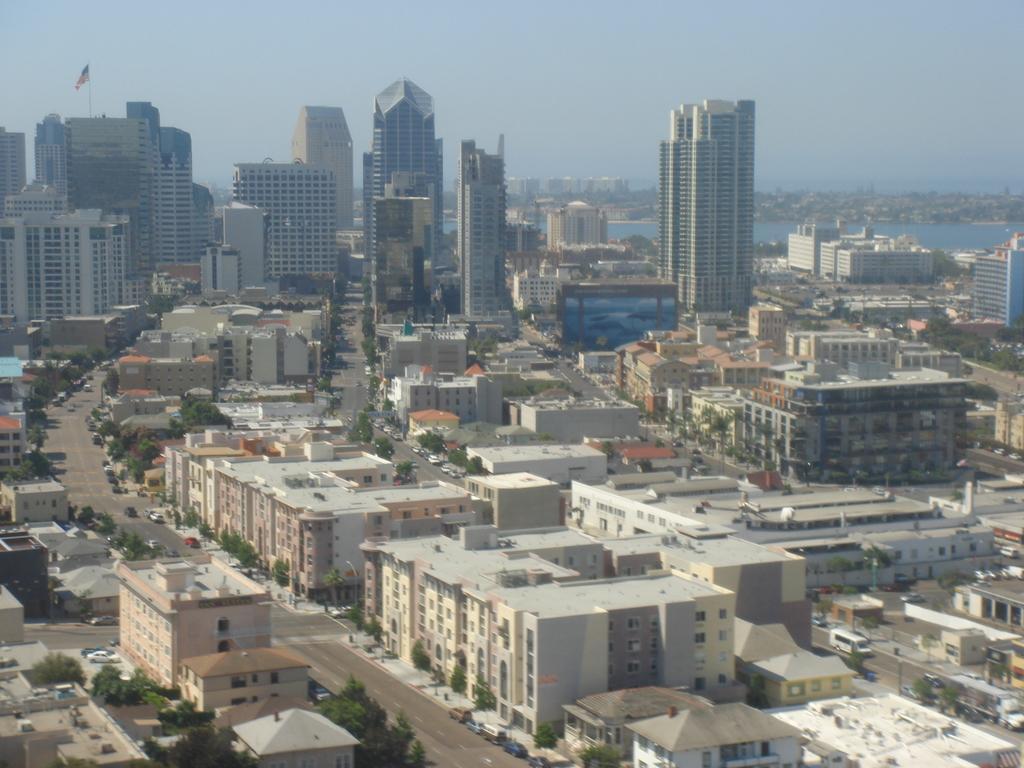In one or two sentences, can you explain what this image depicts? In this image we can see the buildings, trees and also the vehicles on the road. We can also see the flag and also water. Sky is also visible. 